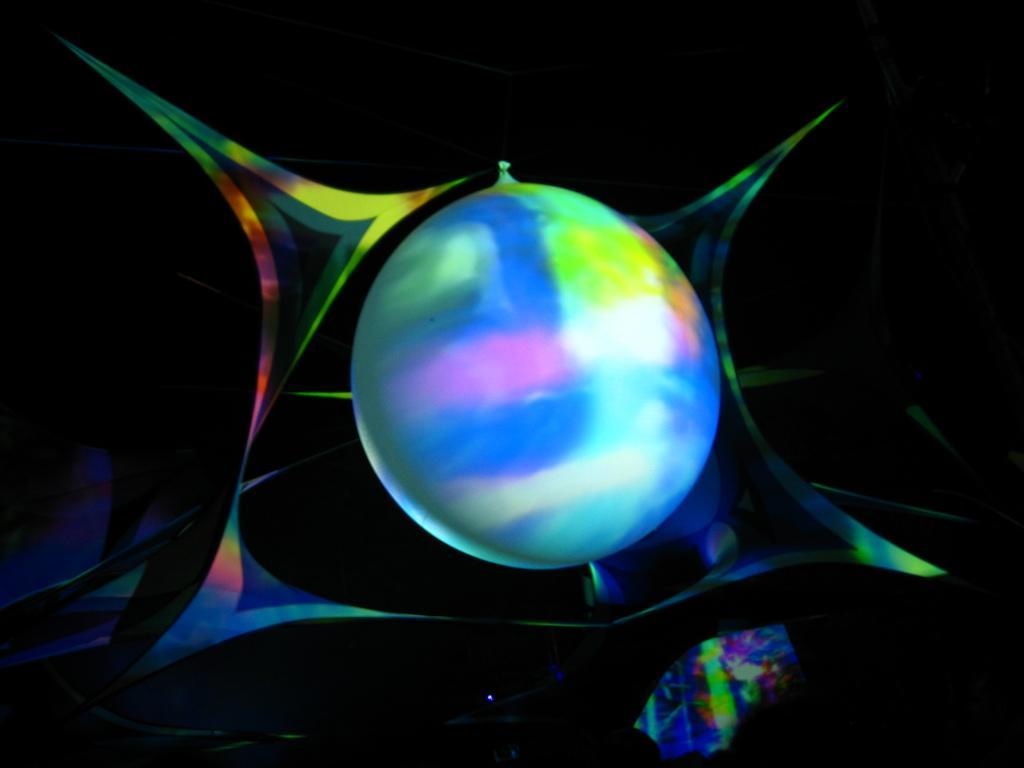In one or two sentences, can you explain what this image depicts? We can able to see a balloon, which has different colors. 